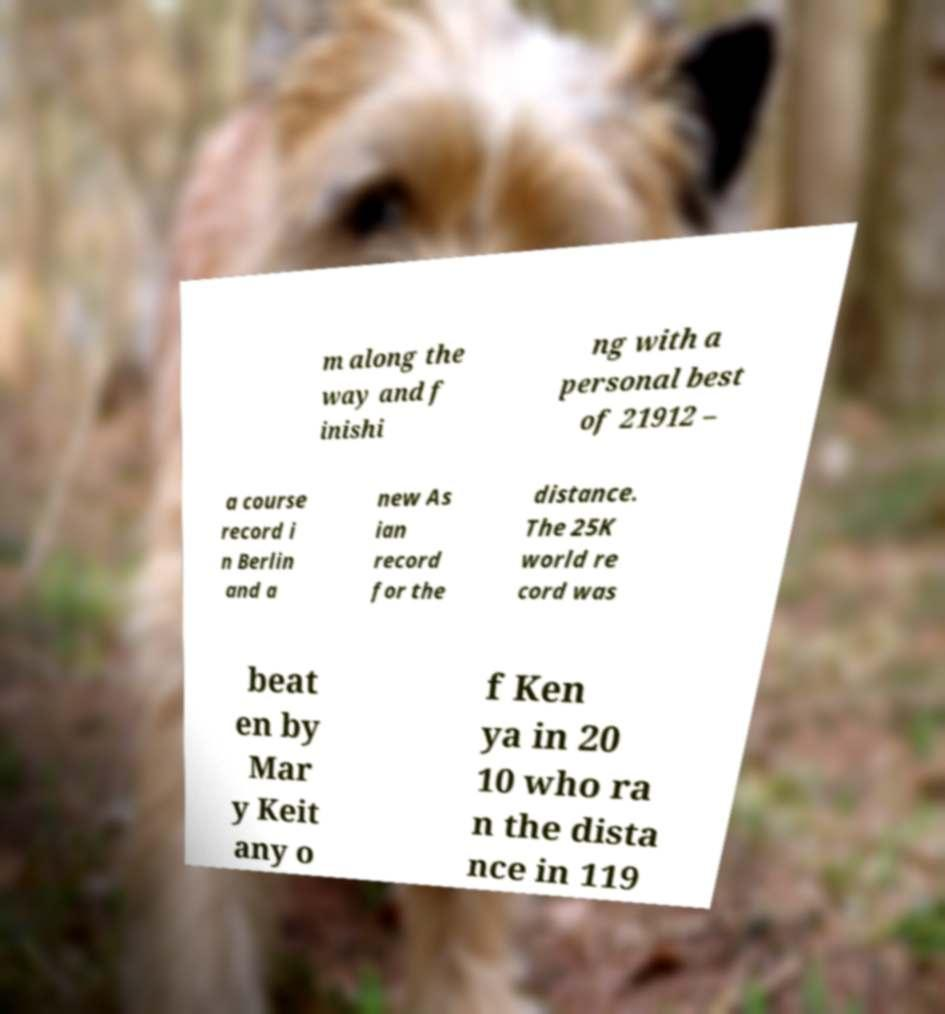I need the written content from this picture converted into text. Can you do that? m along the way and f inishi ng with a personal best of 21912 – a course record i n Berlin and a new As ian record for the distance. The 25K world re cord was beat en by Mar y Keit any o f Ken ya in 20 10 who ra n the dista nce in 119 